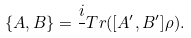Convert formula to latex. <formula><loc_0><loc_0><loc_500><loc_500>\{ A , B \} = \frac { i } { } T r ( [ A ^ { \prime } , B ^ { \prime } ] \rho ) .</formula> 